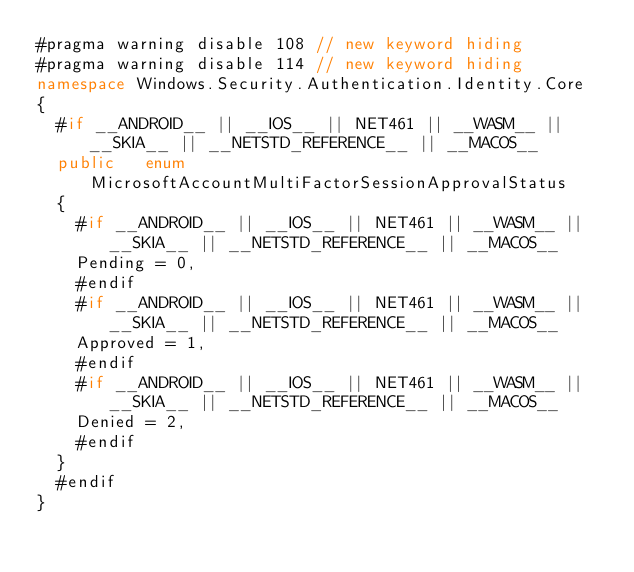<code> <loc_0><loc_0><loc_500><loc_500><_C#_>#pragma warning disable 108 // new keyword hiding
#pragma warning disable 114 // new keyword hiding
namespace Windows.Security.Authentication.Identity.Core
{
	#if __ANDROID__ || __IOS__ || NET461 || __WASM__ || __SKIA__ || __NETSTD_REFERENCE__ || __MACOS__
	public   enum MicrosoftAccountMultiFactorSessionApprovalStatus 
	{
		#if __ANDROID__ || __IOS__ || NET461 || __WASM__ || __SKIA__ || __NETSTD_REFERENCE__ || __MACOS__
		Pending = 0,
		#endif
		#if __ANDROID__ || __IOS__ || NET461 || __WASM__ || __SKIA__ || __NETSTD_REFERENCE__ || __MACOS__
		Approved = 1,
		#endif
		#if __ANDROID__ || __IOS__ || NET461 || __WASM__ || __SKIA__ || __NETSTD_REFERENCE__ || __MACOS__
		Denied = 2,
		#endif
	}
	#endif
}
</code> 